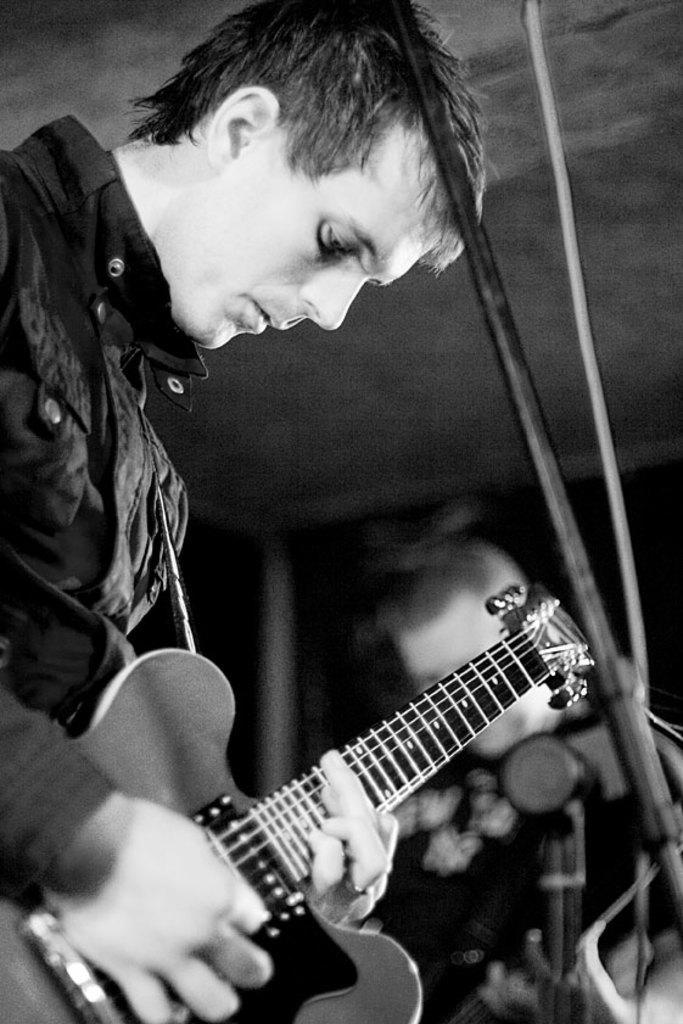How would you summarize this image in a sentence or two? There are two persons. They are standing and they are playing a musical instruments. They both are wearing black jacket. 